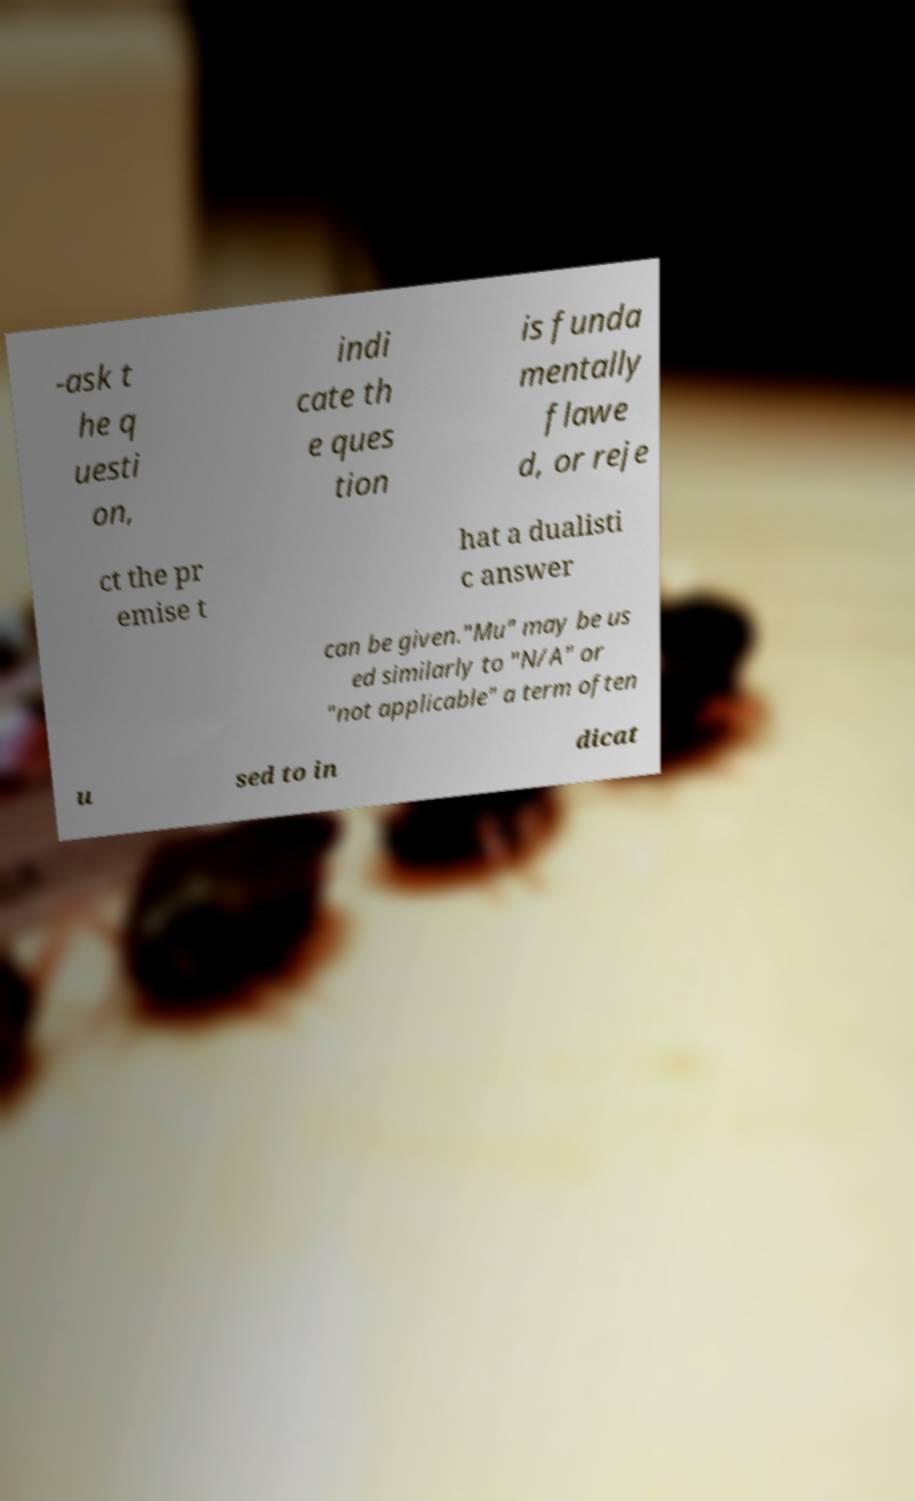There's text embedded in this image that I need extracted. Can you transcribe it verbatim? -ask t he q uesti on, indi cate th e ques tion is funda mentally flawe d, or reje ct the pr emise t hat a dualisti c answer can be given."Mu" may be us ed similarly to "N/A" or "not applicable" a term often u sed to in dicat 